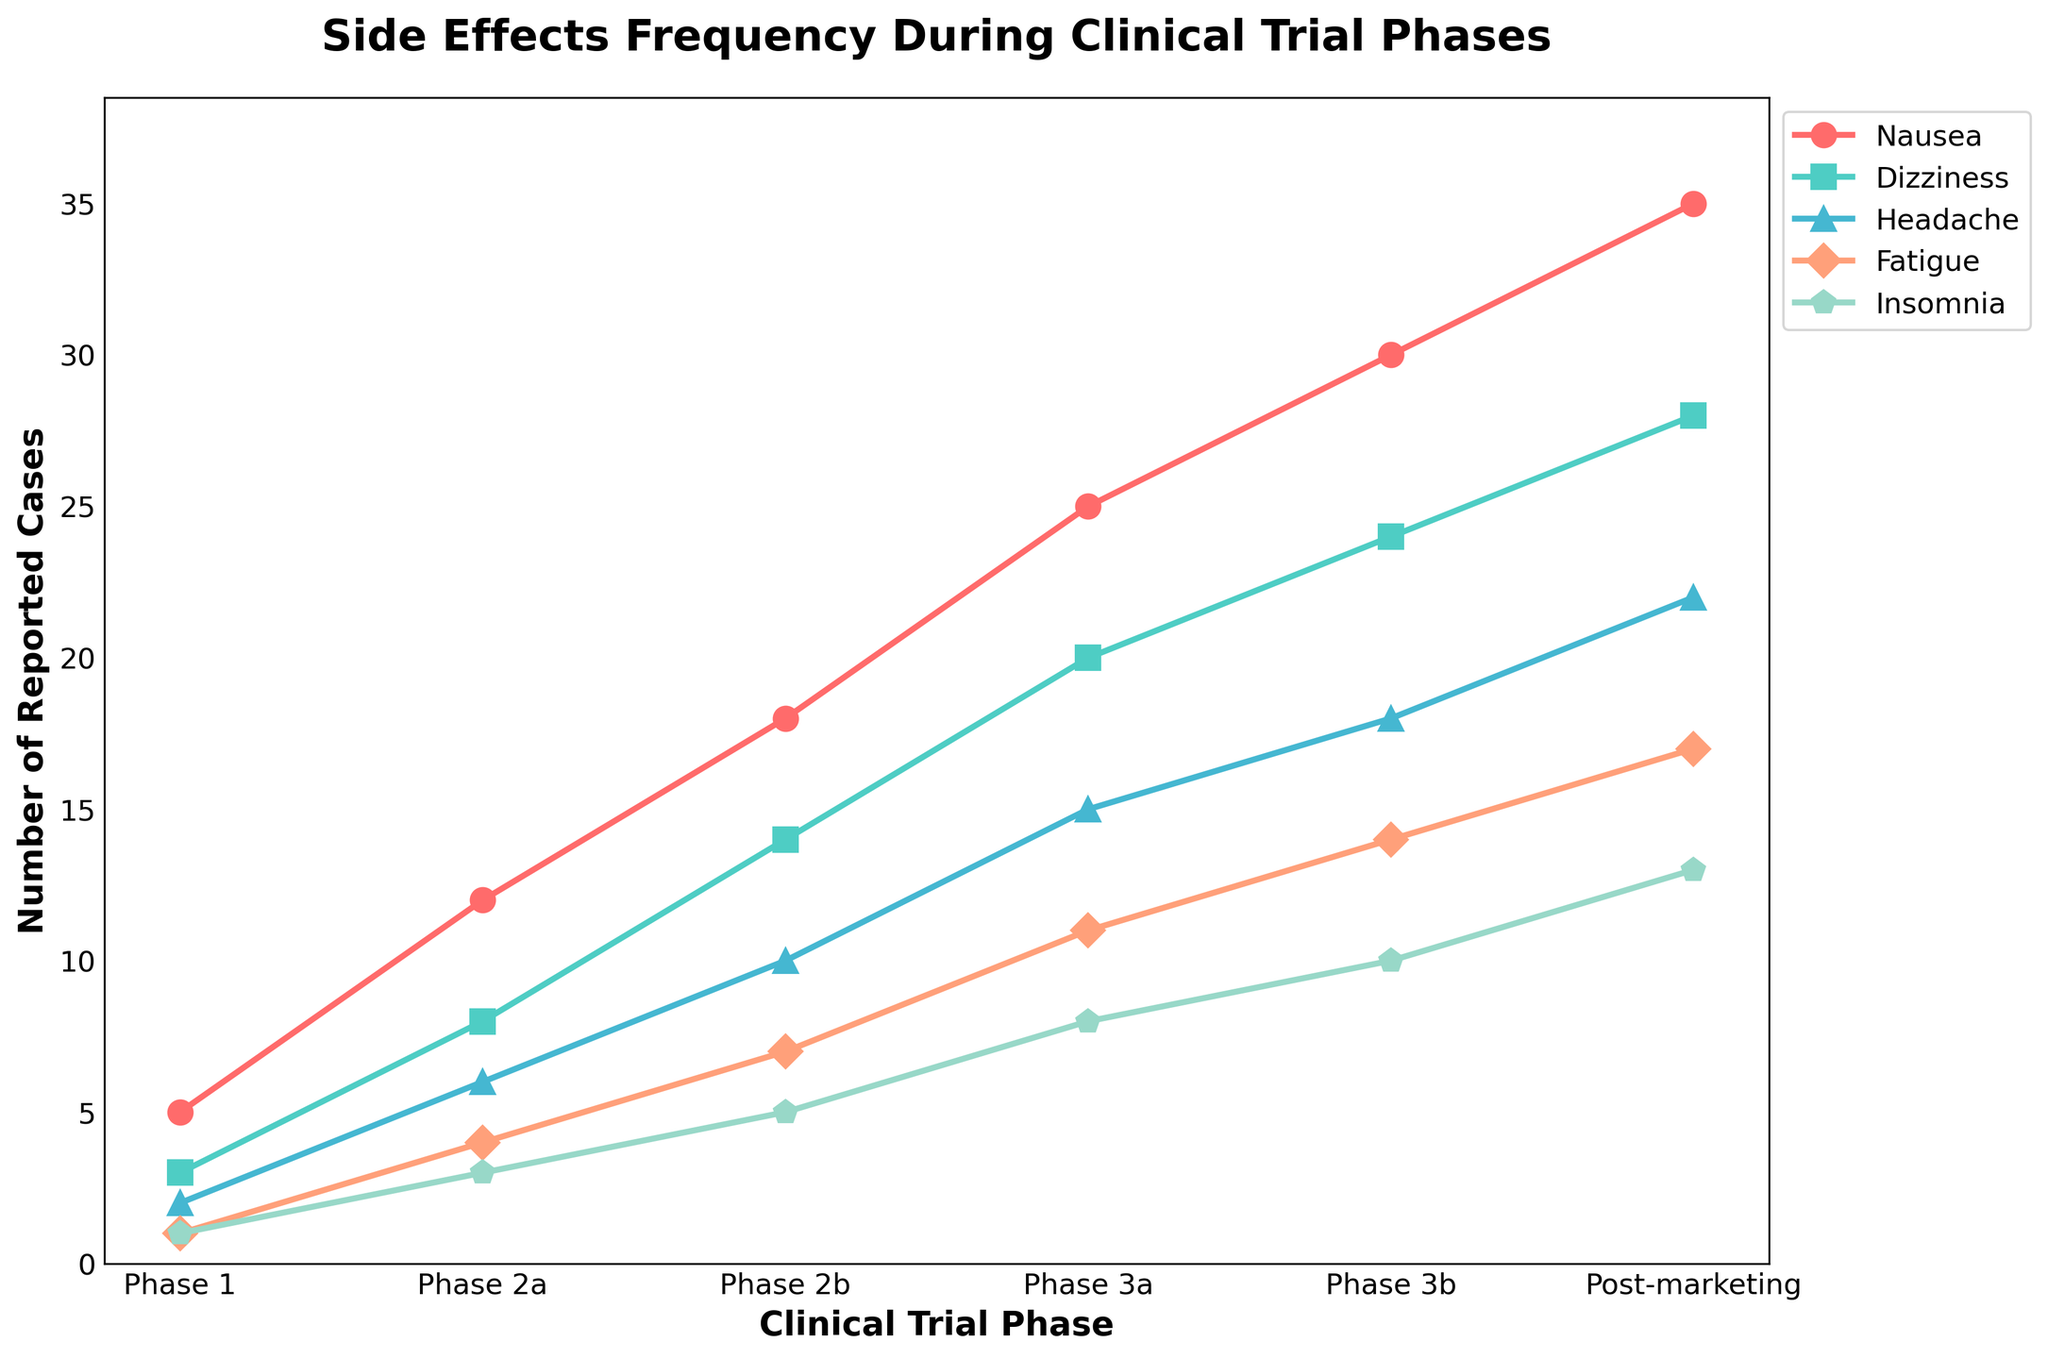What is the trend of reported cases of nausea from Phase 1 to Post-marketing? The trend shows a continuous increase in the number of reported cases of nausea. It starts at 5 cases in Phase 1 and increases gradually, reaching 35 cases in the Post-marketing phase.
Answer: Continuous increase Which phase has the highest number of reported cases of fatigue? By comparing the reported cases of fatigue across all phases, Post-marketing has the highest number of reported cases with 17 cases.
Answer: Post-marketing How much did the number of reported dizziness cases increase from Phase 2a to Phase 3a? The number of reported dizziness cases in Phase 2a is 8, and in Phase 3a it is 20. The increase is calculated by the difference: 20 - 8 = 12.
Answer: 12 What is the combined total of reported cases of insomnia and headache in Phase 3b? In Phase 3b, there are 10 reported cases of insomnia and 18 reported cases of headache. Their combined total is calculated by adding the two: 10 + 18 = 28.
Answer: 28 Which side effect shows the steepest increase in reported cases between any two consecutive phases? To find the steepest increase, compare the differences in reported cases between consecutive phases for each side effect. Nausea shows the steepest increase from Phase 2b to Phase 3a, with a rise from 18 to 25 cases. The increase is 25 - 18 = 7.
Answer: Nausea What is the average number of reported cases of dizziness throughout all phases? The numbers of reported dizziness cases are 3, 8, 14, 20, 24, and 28. The average is calculated by summing these values and dividing by the number of phases: (3 + 8 + 14 + 20 + 24 + 28)/6 = 97/6 ≈ 16.17.
Answer: 16.17 Is the number of reported insomnia cases in Phase 3a greater than, less than, or equal to the number of reported fatigue cases in Phase 2b? In Phase 3a, there are 8 reported cases of insomnia, and in Phase 2b, there are 7 reported cases of fatigue. Since 8 is greater than 7, the number of reported insomnia cases in Phase 3a is greater.
Answer: Greater than Which side effect has the highest total number of reported cases across all phases? Sum the reported cases for each side effect across all phases: 
- Nausea: 5 + 12 + 18 + 25 + 30 + 35 = 125 
- Dizziness: 3 + 8 + 14 + 20 + 24 + 28 = 97
- Headache: 2 + 6 + 10 + 15 + 18 + 22 = 73
- Fatigue: 1 + 4 + 7 + 11 + 14 + 17 = 54
- Insomnia: 1 + 3 + 5 + 8 + 10 + 13 = 40 
Nausea has the highest total number of reported cases, with 125 cases.
Answer: Nausea 